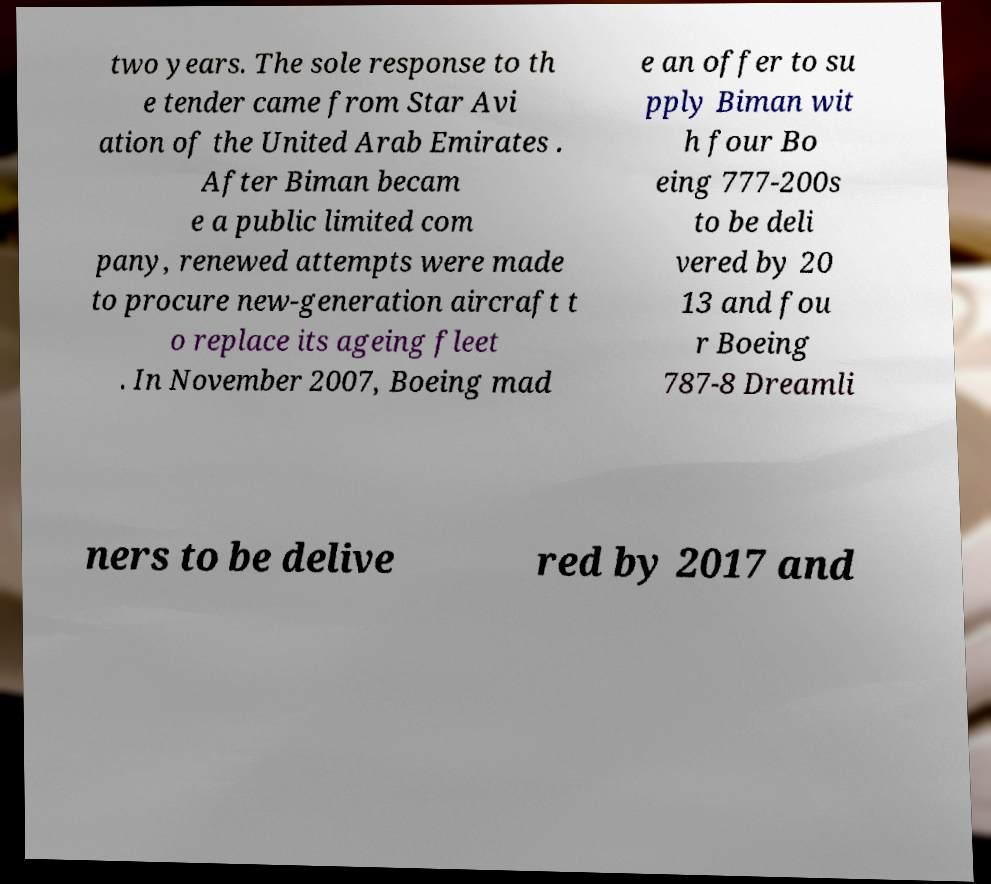Please identify and transcribe the text found in this image. two years. The sole response to th e tender came from Star Avi ation of the United Arab Emirates . After Biman becam e a public limited com pany, renewed attempts were made to procure new-generation aircraft t o replace its ageing fleet . In November 2007, Boeing mad e an offer to su pply Biman wit h four Bo eing 777-200s to be deli vered by 20 13 and fou r Boeing 787-8 Dreamli ners to be delive red by 2017 and 